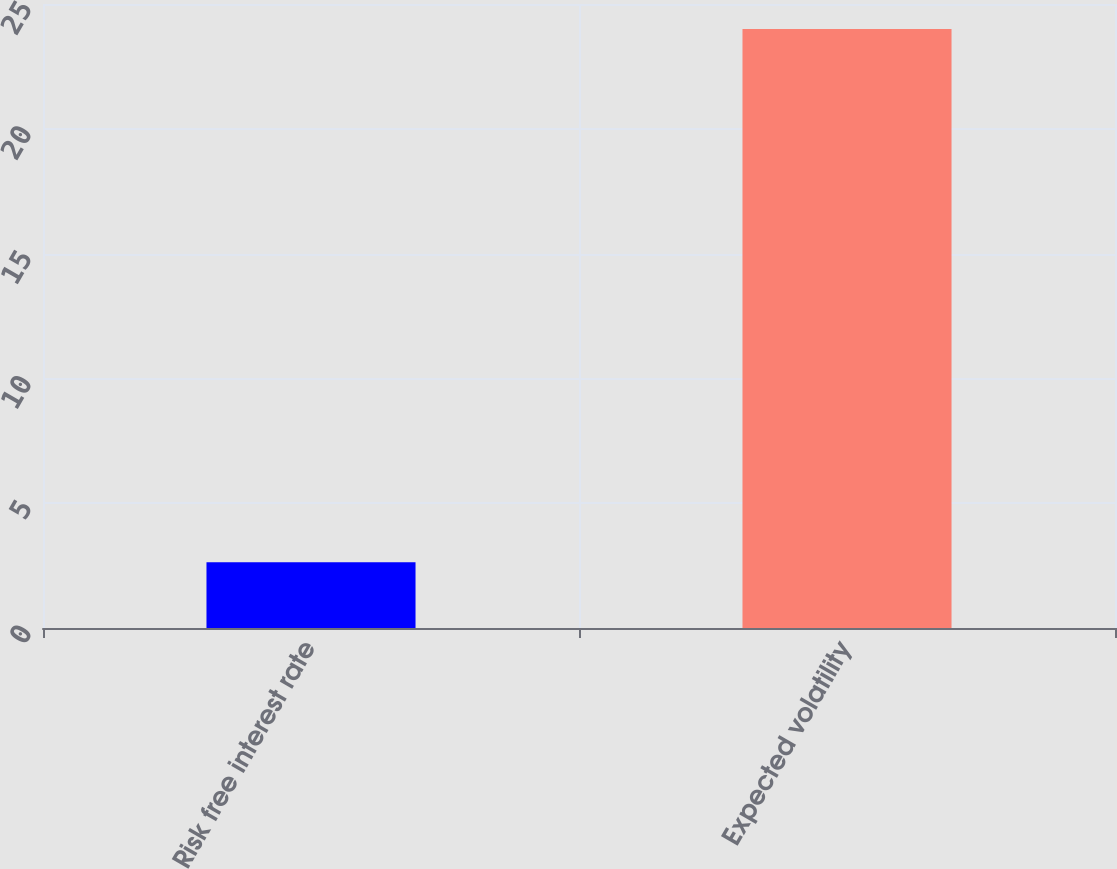<chart> <loc_0><loc_0><loc_500><loc_500><bar_chart><fcel>Risk free interest rate<fcel>Expected volatility<nl><fcel>2.63<fcel>24<nl></chart> 